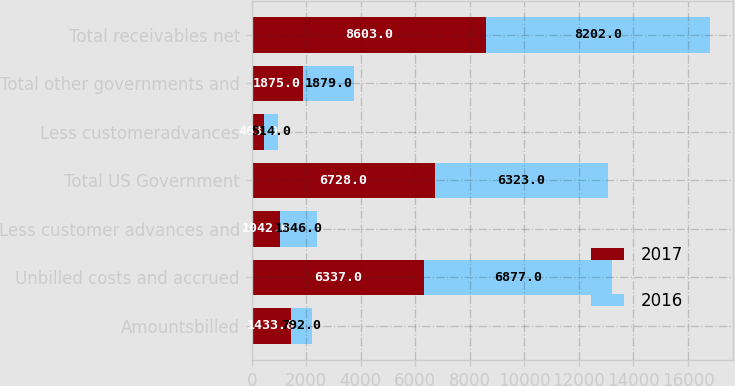<chart> <loc_0><loc_0><loc_500><loc_500><stacked_bar_chart><ecel><fcel>Amountsbilled<fcel>Unbilled costs and accrued<fcel>Less customer advances and<fcel>Total US Government<fcel>Less customeradvances<fcel>Total other governments and<fcel>Total receivables net<nl><fcel>2017<fcel>1433<fcel>6337<fcel>1042<fcel>6728<fcel>463<fcel>1875<fcel>8603<nl><fcel>2016<fcel>792<fcel>6877<fcel>1346<fcel>6323<fcel>514<fcel>1879<fcel>8202<nl></chart> 